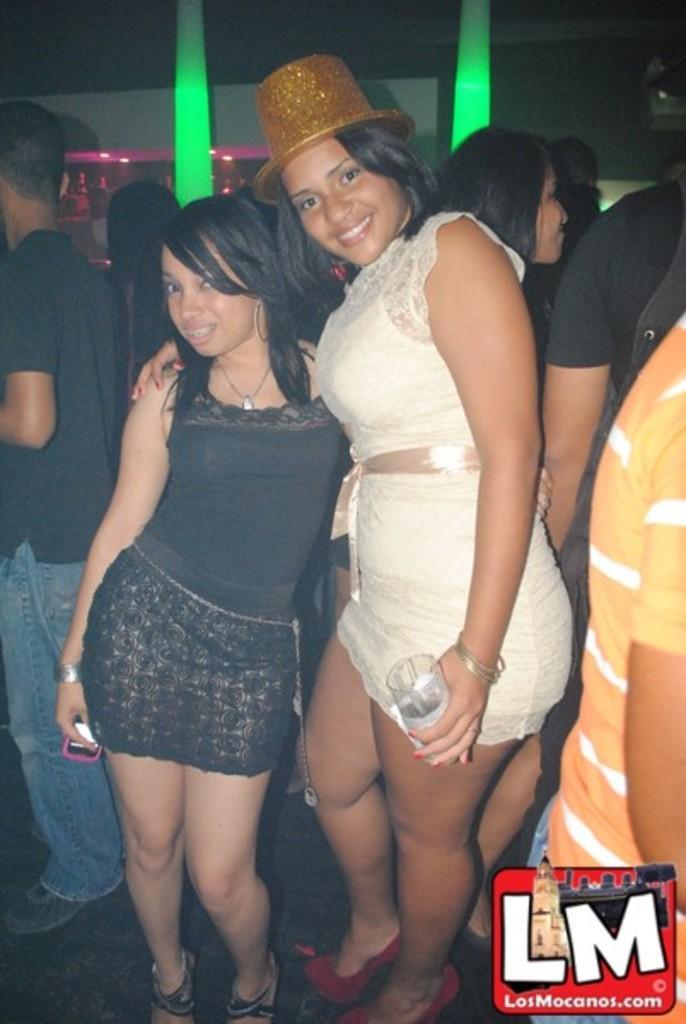Could you give a brief overview of what you see in this image? The woman in white dress and the woman in black dress are standing in front of the picture. She is holding the glass in her hands. Both of them are smiling. Behind them, we see people standing. In the background, we see the green color cloth and a wall in white color. 